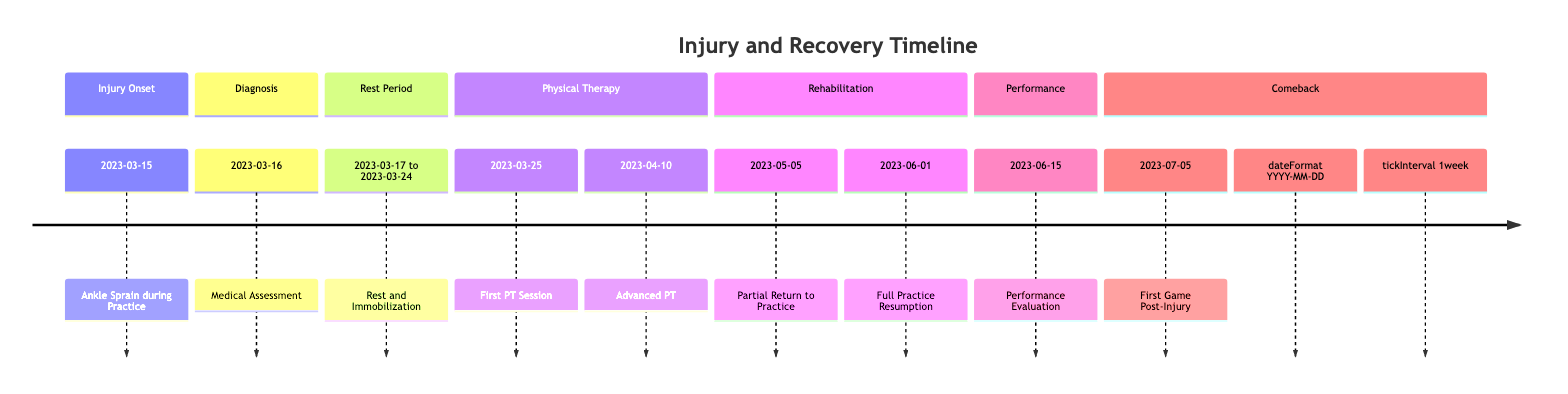What event occurred on March 15, 2023? The diagram shows that on March 15, 2023, the event "Ankle Sprain during Practice" occurred in the "Injury Onset" phase.
Answer: Ankle Sprain during Practice What was done on March 16, 2023? On March 16, 2023, there was a "Medical Assessment" where a visit to Dr. Emily Carter was conducted, as indicated in the timeline.
Answer: Medical Assessment How long did the rest period last? The rest period lasted from March 17, 2023, to March 24, 2023, which is a total of 8 days, as calculated by counting the days inclusive.
Answer: 8 days What did physical therapy begin on March 25, 2023, focus on? The first physical therapy session on March 25, 2023, focused on reducing swelling and pain through controlled exercises, as stated in the description of that event.
Answer: Reducing swelling and pain What is the date of the first game post-injury? The first game post-injury is clearly indicated as occurring on July 5, 2023, within the "Comeback" section of the timeline.
Answer: July 5, 2023 How many key phases of recovery are in the timeline? The timeline is divided into 7 key phases: Injury Onset, Diagnosis, Rest Period, Physical Therapy, Rehabilitation, Performance, and Comeback, making a total of 7 phases.
Answer: 7 phases What significant milestone occurred on June 15, 2023? On June 15, 2023, the significant milestone was a "Performance Evaluation" where metrics testing was conducted to assess the recovery progress.
Answer: Performance Evaluation What types of activities were included in the strengthening phase? The strengthening phase involved balance and strength exercises, including the use of resistance bands and swimming for low-impact conditioning, as detailed in the phase description.
Answer: Balance and strength exercises What was the primary focus during the first physical therapy session? The primary focus during the first physical therapy session was to control swelling and pain through specific exercises, as explicitly mentioned in the description.
Answer: Controlled exercises 